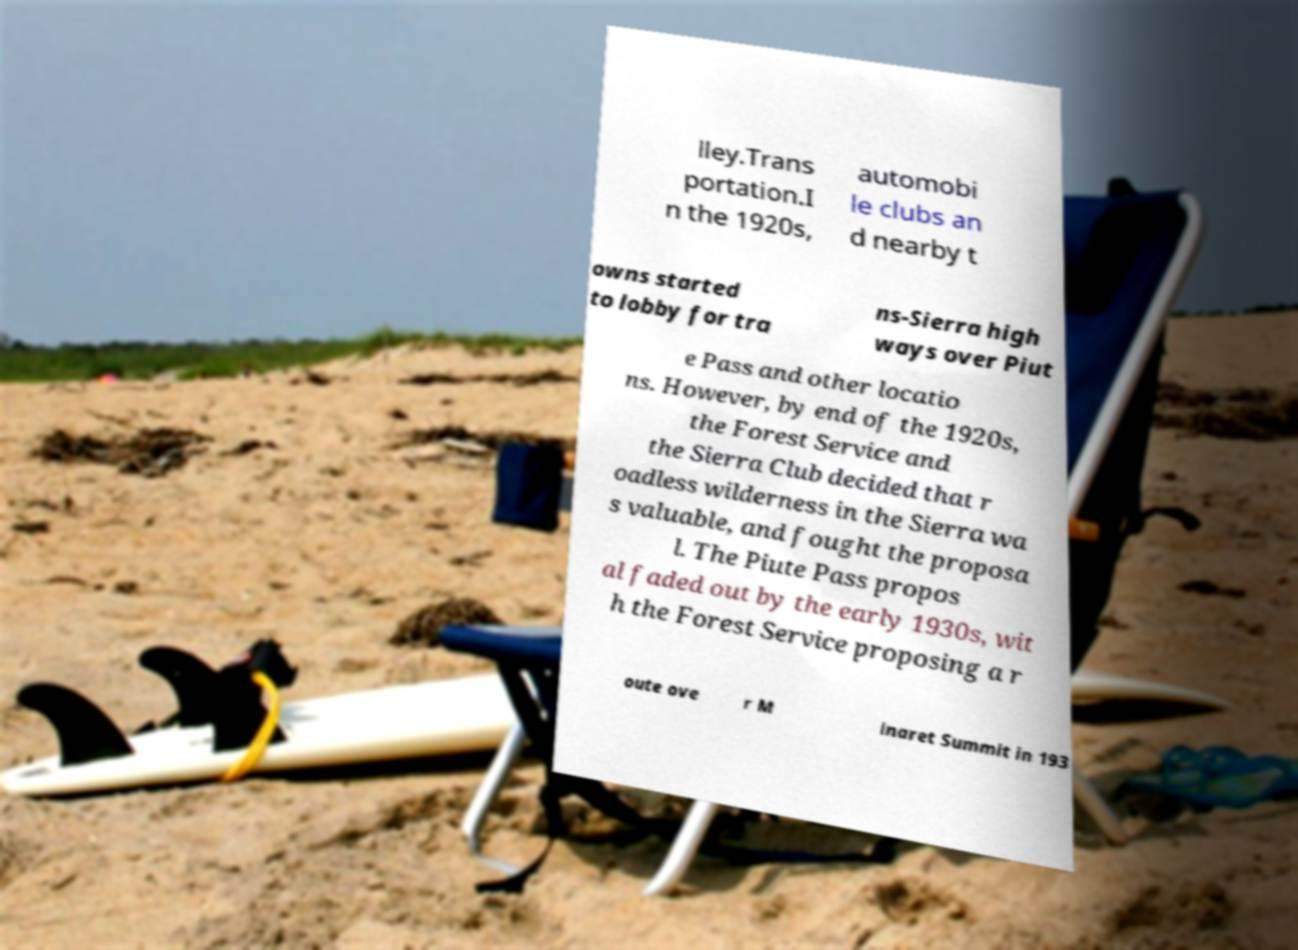What messages or text are displayed in this image? I need them in a readable, typed format. lley.Trans portation.I n the 1920s, automobi le clubs an d nearby t owns started to lobby for tra ns-Sierra high ways over Piut e Pass and other locatio ns. However, by end of the 1920s, the Forest Service and the Sierra Club decided that r oadless wilderness in the Sierra wa s valuable, and fought the proposa l. The Piute Pass propos al faded out by the early 1930s, wit h the Forest Service proposing a r oute ove r M inaret Summit in 193 